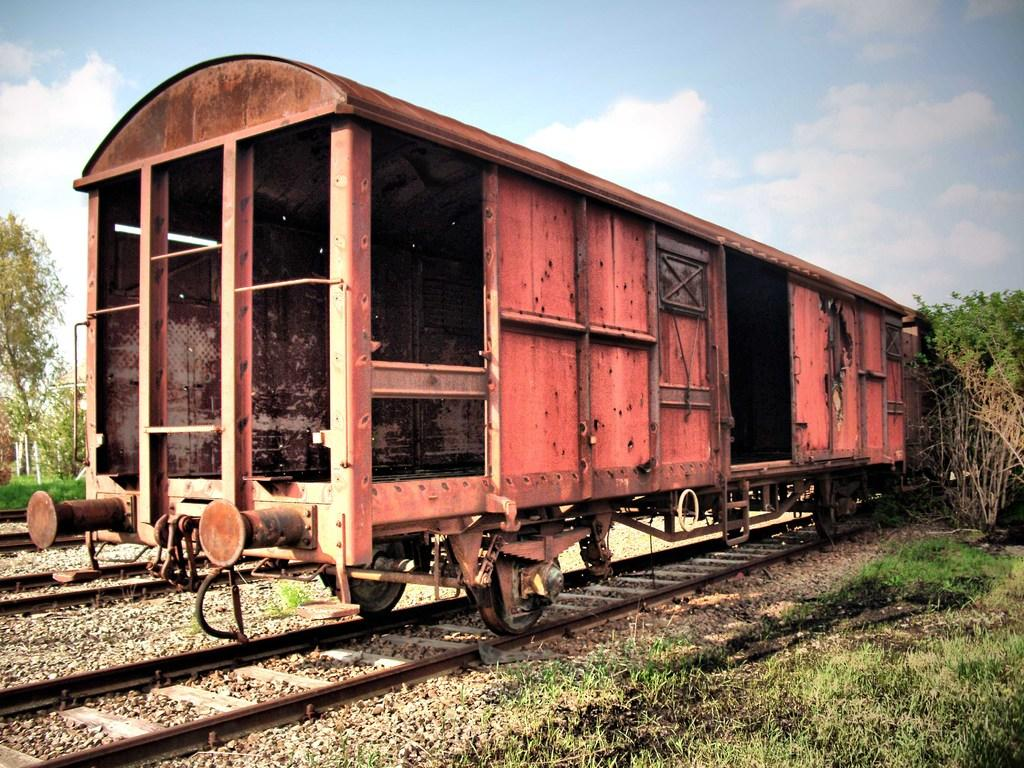What is located on the train track in the image? There is a train compartment on the train track. How would you describe the sky in the image? The sky is cloudy in the image. What type of vegetation can be seen in the image? There are trees visible in the image. What is the ground covered with in the image? There is grass visible in the image. What finger is used to apply the paste to the train compartment in the image? There is no finger or paste present in the image; it features a train compartment on a train track with a cloudy sky and vegetation. 